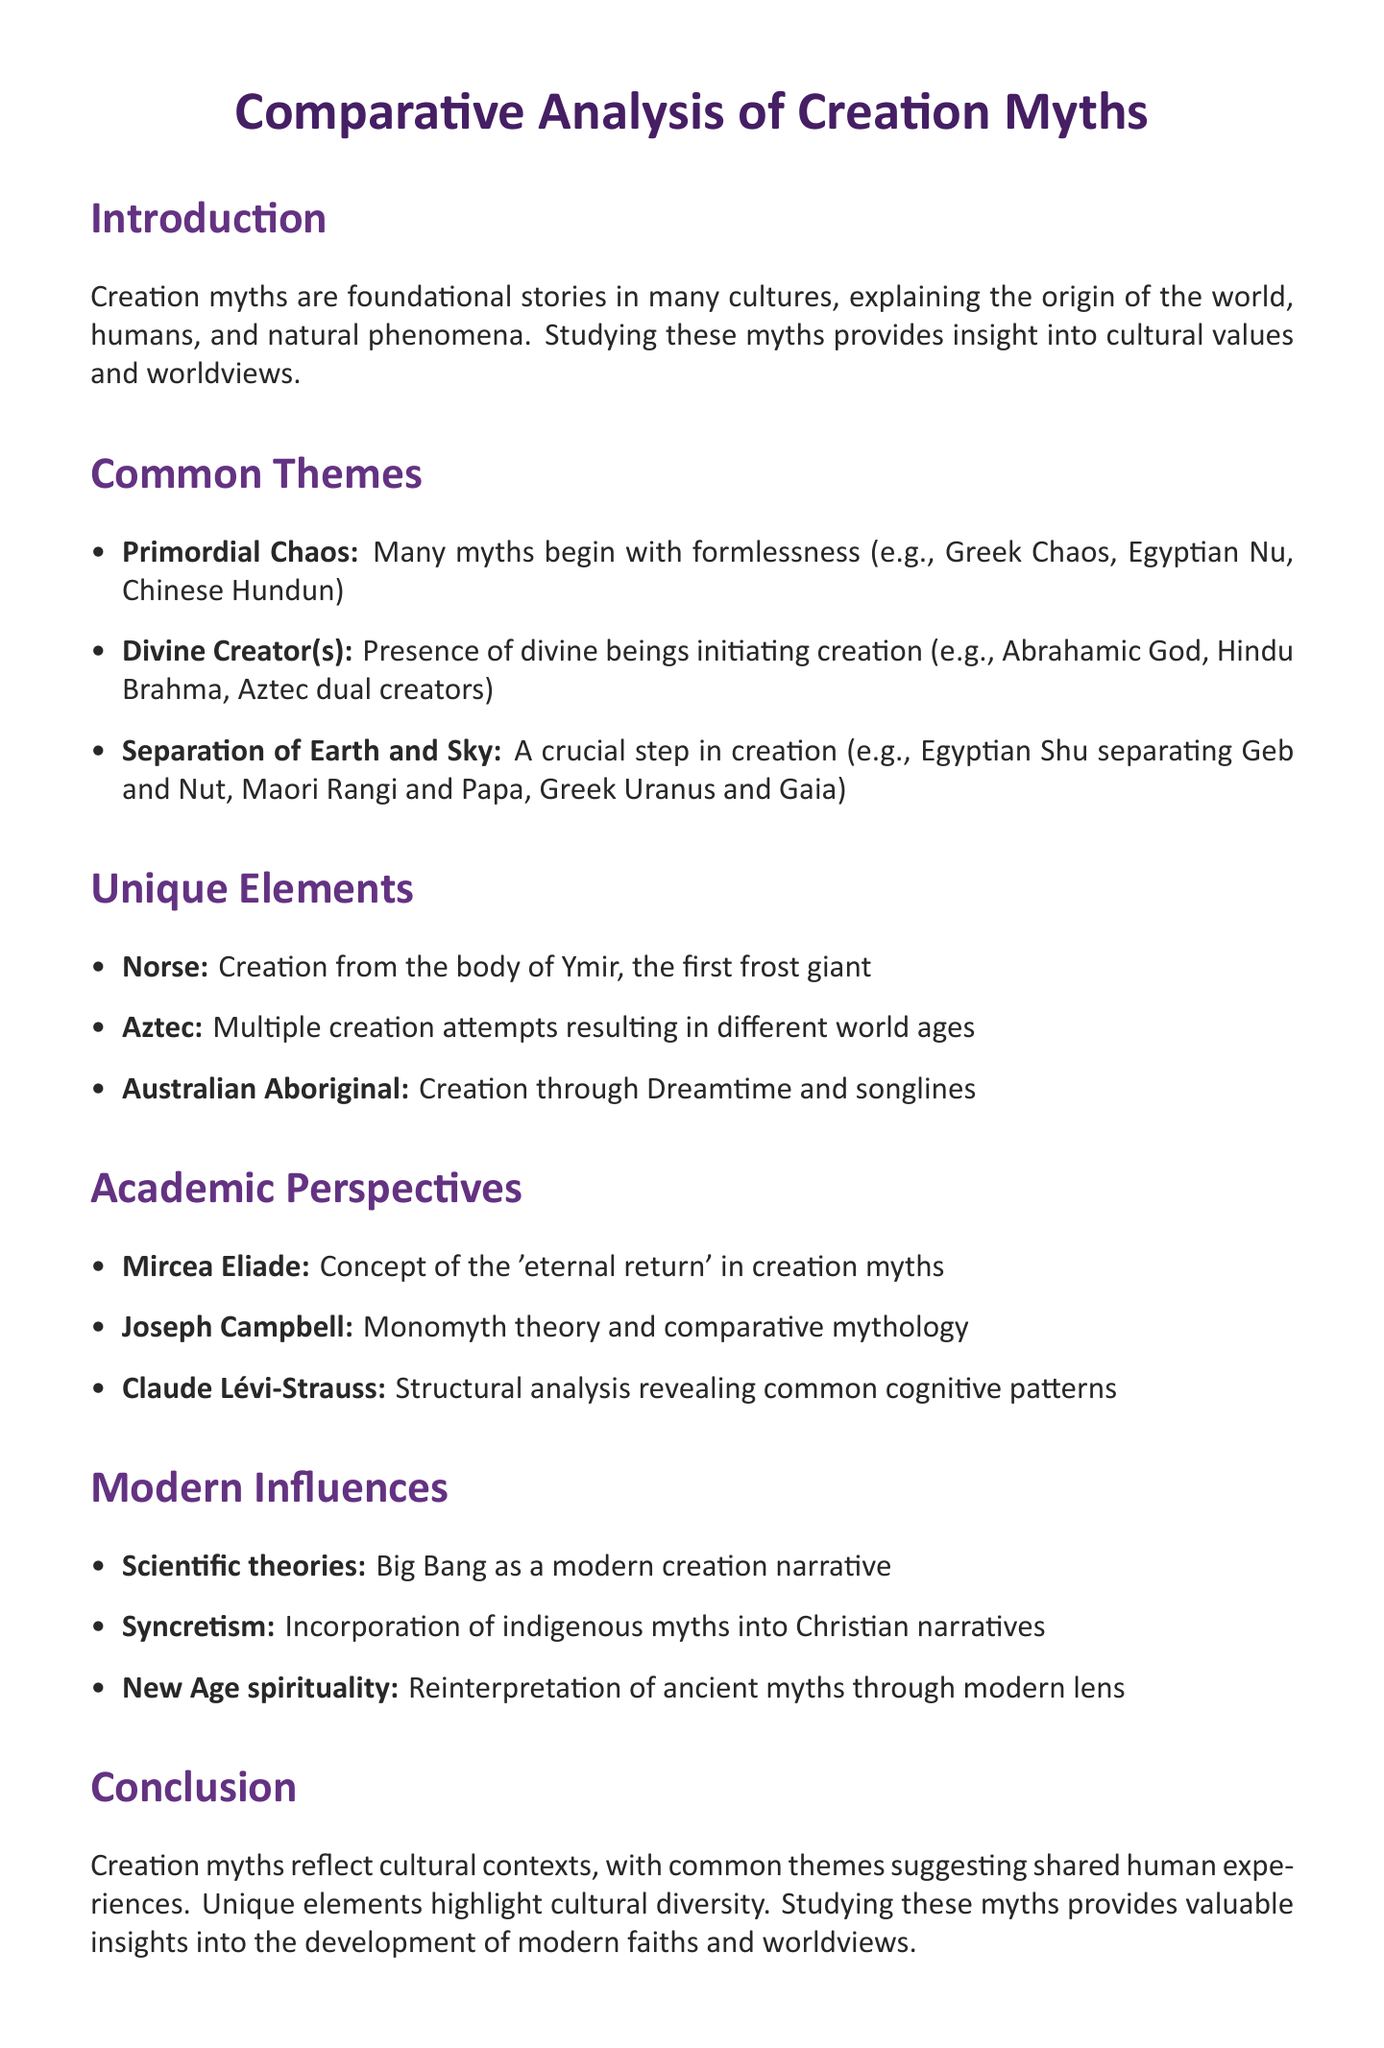What are creation myths? Creation myths are foundational stories in many cultures, explaining the origin of the world, humans, and natural phenomena.
Answer: Foundational stories Name one example of Primordial Chaos. This refers to the element of chaos in creation myths, with examples such as Chaos in Greek mythology.
Answer: Greek mythology: Chaos Who is the creator god in Hindu mythology? The document mentions Brahma as the creator god in Hindu mythology.
Answer: Brahma What unique feature does Norse mythology have? This refers to a specific element within Norse mythology's creation narrative, which is described in the document.
Answer: Creation from the body of a primordial giant Which scholar contributed the concept of 'eternal return'? This question looks for the name of the scholar mentioned in the academic perspectives section.
Answer: Mircea Eliade How does New Age spirituality influence creation myths? This question asks for the impact of New Age spirituality on traditional myths as described in the document.
Answer: Reinterpretation of ancient creation myths What do common themes in creation myths suggest? The document provides insights into what common themes across cultures indicate about human experiences.
Answer: Shared human experiences How many unique elements are listed in the document? This refers to the number of unique elements described in the section regarding distinct cultural aspects.
Answer: Three unique elements 